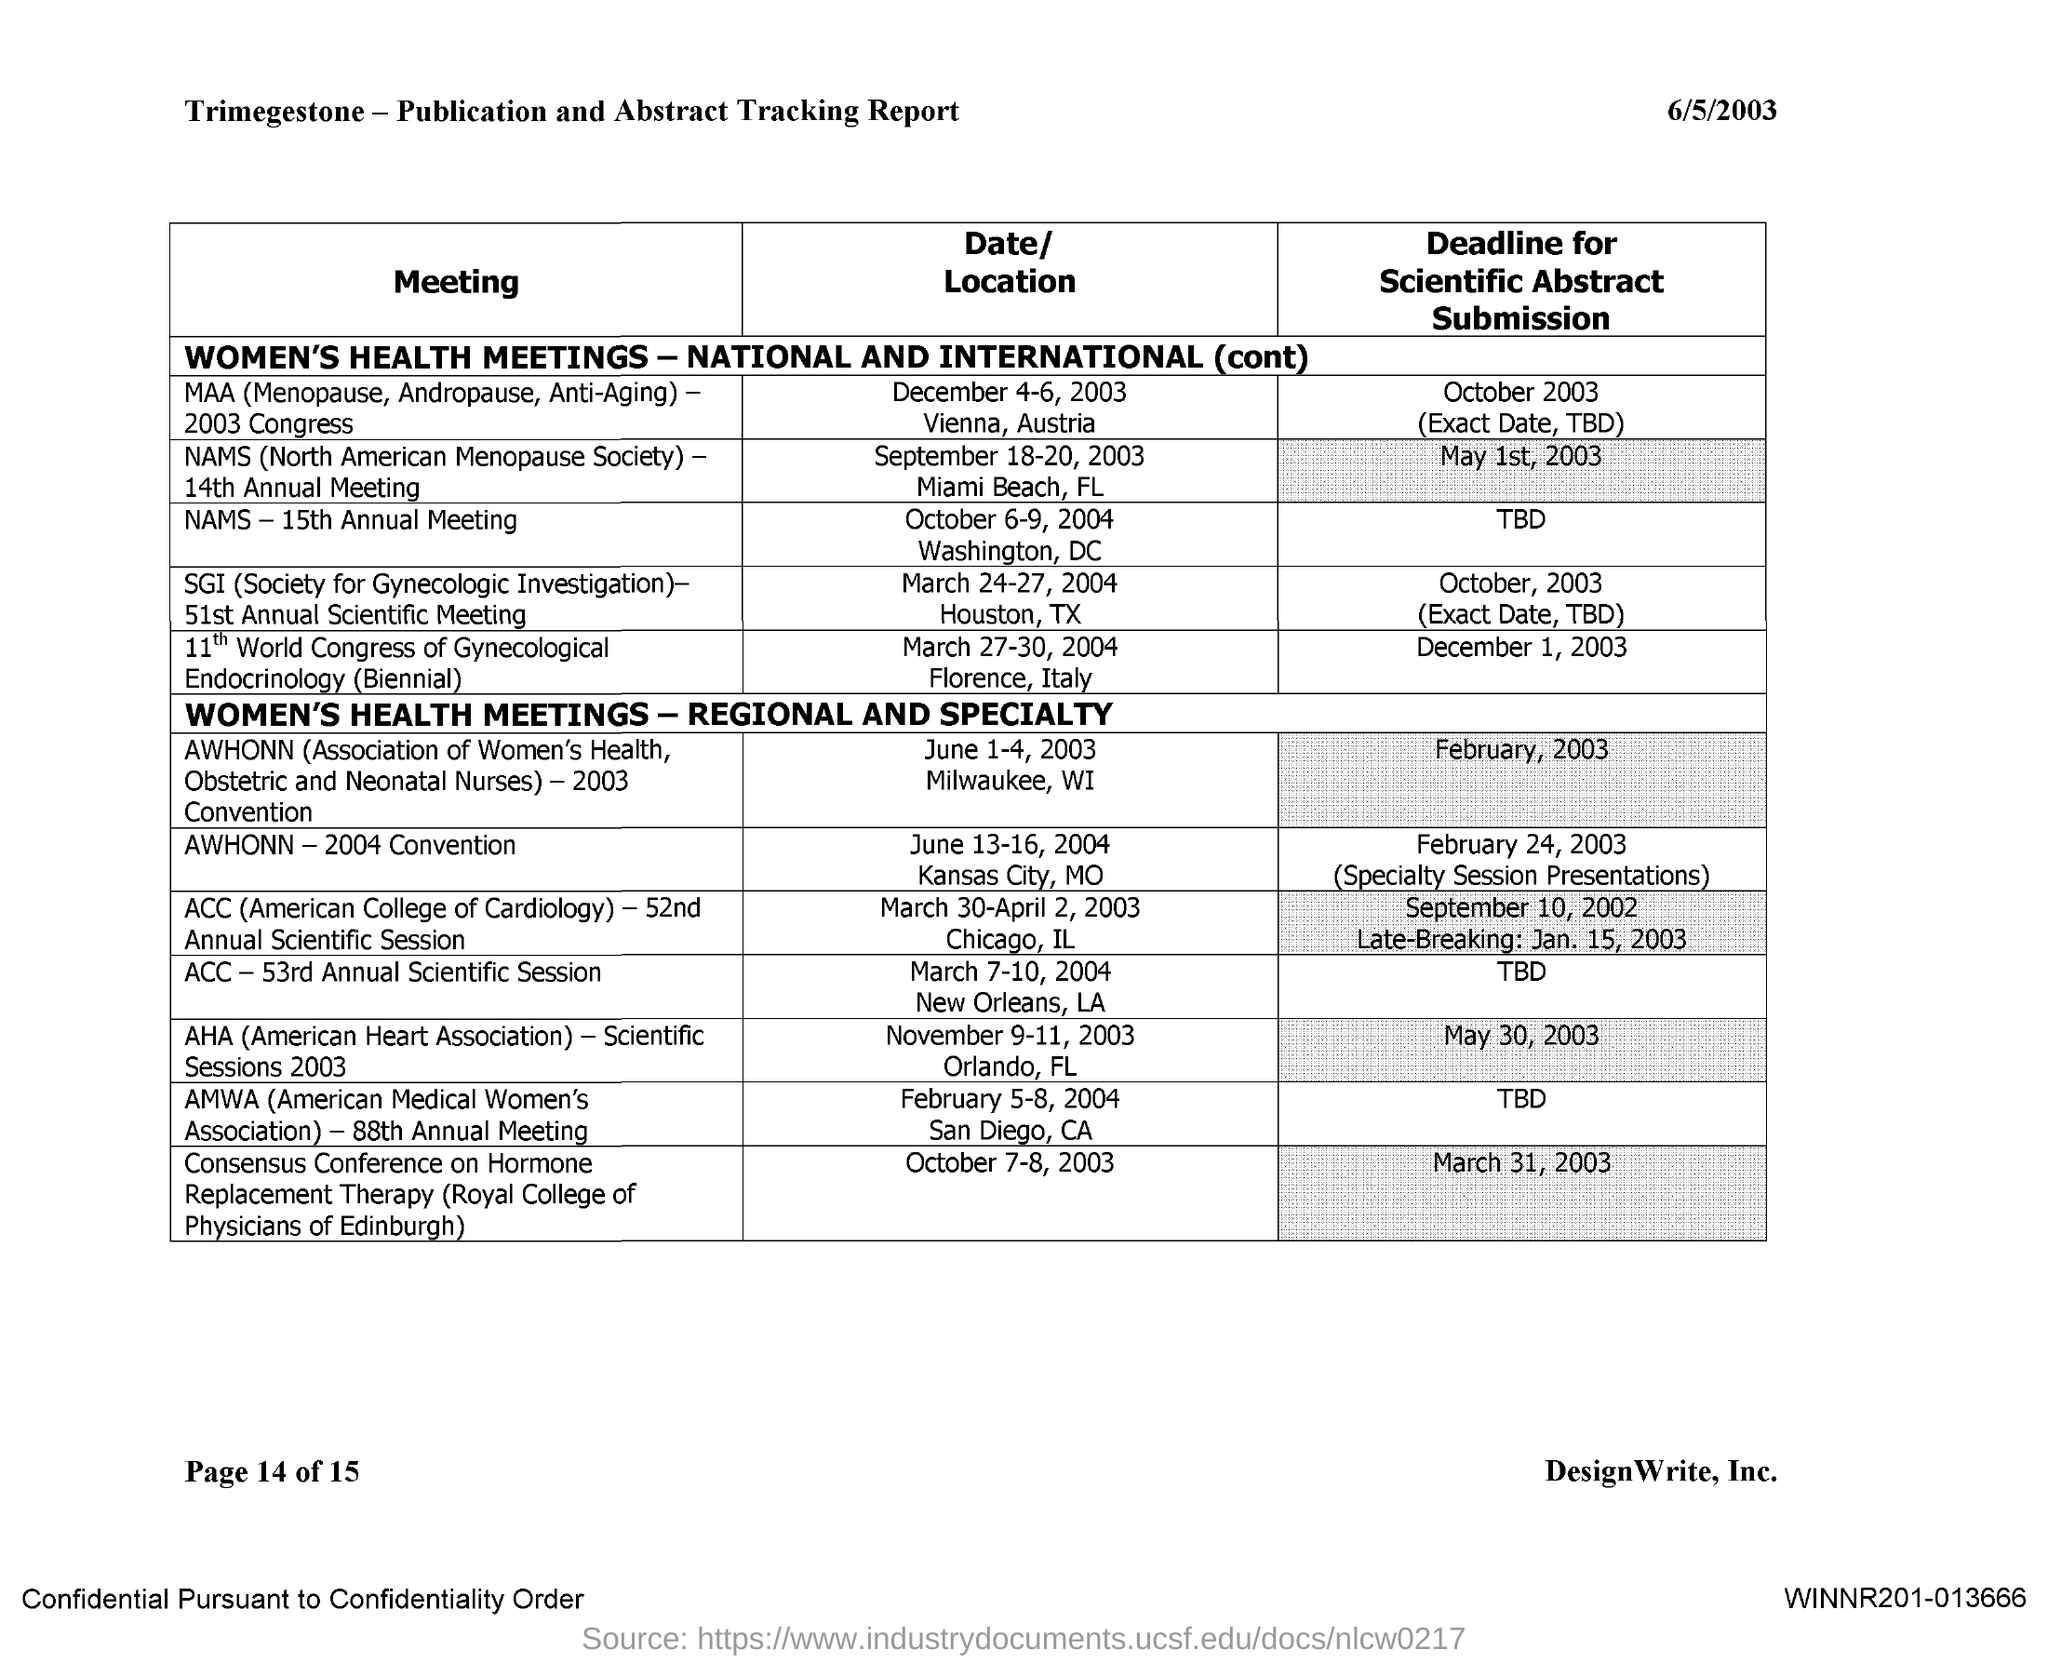What is the deadline for Scientific abstract submission for NAMS - 14th Annual Meeting?
Give a very brief answer. May 1st, 2003. What is the deadline for Scientific abstract submission for NAMS - 15th Annual Meeting?
Provide a short and direct response. TBD. What is the deadline for Scientific abstract submission for AWHONN - 2003 Convention?
Your answer should be compact. February, 2003. What is the deadline for Scientific abstract submission for AWHONN - 2004 Convention?
Offer a very short reply. February 24, 2003 (Specialty Session Presentations). What is the deadline for Scientific abstract submission for ACC - 52nd Annual Scientific Session?
Ensure brevity in your answer.  September 10, 2002. What is the deadline for Scientific abstract submission for ACC - 53rd Annual Scientific Session?
Offer a very short reply. TBD. What is the deadline for Scientific abstract submission for AHA - Scientific SessionS 2003?
Your answer should be compact. May 30, 2003. What is the deadline for Scientific abstract submission for AMWA - 88TH Annual Meeting?
Your response must be concise. TBD. 